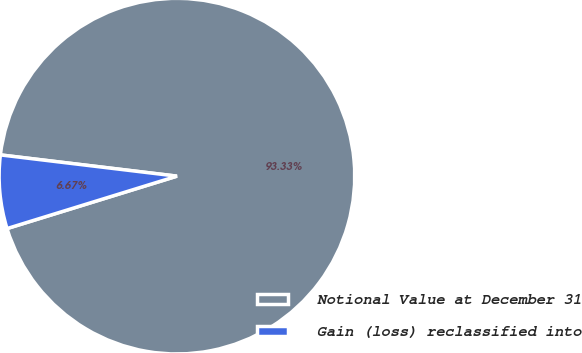Convert chart to OTSL. <chart><loc_0><loc_0><loc_500><loc_500><pie_chart><fcel>Notional Value at December 31<fcel>Gain (loss) reclassified into<nl><fcel>93.33%<fcel>6.67%<nl></chart> 